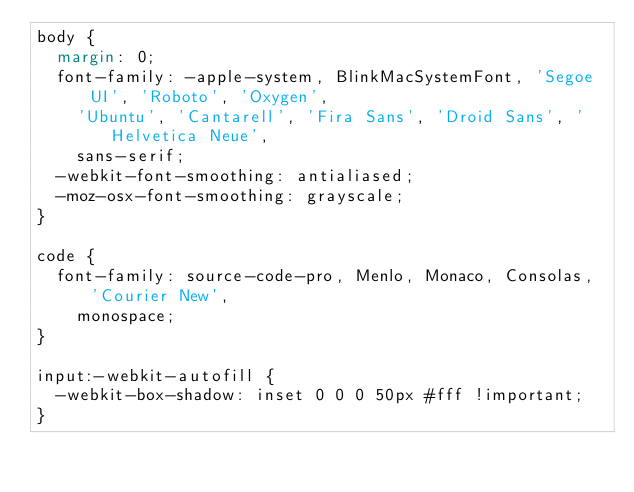<code> <loc_0><loc_0><loc_500><loc_500><_CSS_>body {
  margin: 0;
  font-family: -apple-system, BlinkMacSystemFont, 'Segoe UI', 'Roboto', 'Oxygen',
    'Ubuntu', 'Cantarell', 'Fira Sans', 'Droid Sans', 'Helvetica Neue',
    sans-serif;
  -webkit-font-smoothing: antialiased;
  -moz-osx-font-smoothing: grayscale;
}

code {
  font-family: source-code-pro, Menlo, Monaco, Consolas, 'Courier New',
    monospace;
}

input:-webkit-autofill {
  -webkit-box-shadow: inset 0 0 0 50px #fff !important;
}</code> 